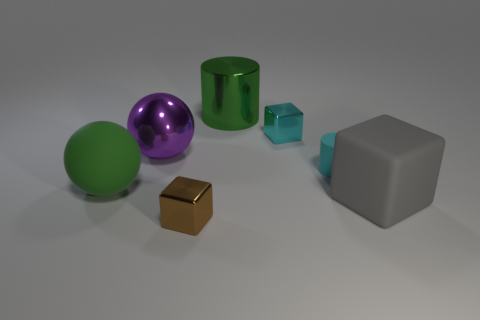Is there another object that has the same shape as the large green metallic thing?
Offer a very short reply. Yes. Does the metal thing that is behind the tiny cyan cube have the same color as the rubber sphere?
Offer a very short reply. Yes. Do the green object that is in front of the big purple metallic thing and the metallic cube in front of the green matte object have the same size?
Provide a short and direct response. No. There is a brown thing that is made of the same material as the large purple thing; what size is it?
Make the answer very short. Small. How many metal objects are both in front of the small cyan shiny object and behind the small cyan matte cylinder?
Give a very brief answer. 1. What number of things are gray matte blocks or objects that are in front of the small rubber thing?
Offer a terse response. 3. There is a large thing that is the same color as the metallic cylinder; what is its shape?
Keep it short and to the point. Sphere. What color is the rubber object to the left of the brown thing?
Your answer should be very brief. Green. How many objects are cylinders that are right of the cyan shiny thing or blue rubber cubes?
Provide a succinct answer. 1. What color is the rubber block that is the same size as the purple ball?
Keep it short and to the point. Gray. 